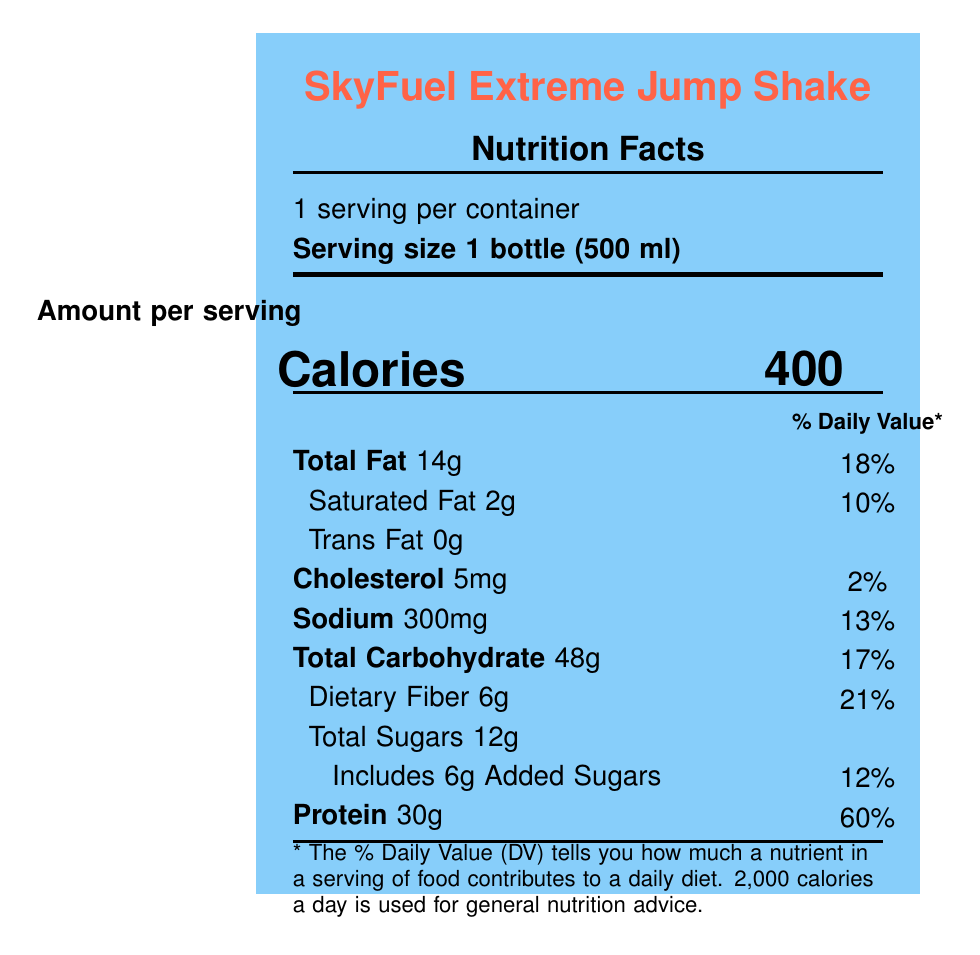what is the serving size? The serving size is shown as "1 bottle (500 ml)" under the "Serving size" section of the document.
Answer: 1 bottle (500 ml) how many servings are there per container? As indicated in the document, there is "1 serving per container."
Answer: 1 how many calories are in one serving? The document clearly states "Calories 400" under the "Amount per serving" section.
Answer: 400 what percentage of the daily value does protein account for? The document shows "Protein 30g" and "60%" next to it, indicating the percentage of the daily value.
Answer: 60% how much dietary fiber does one serving contain? Under the "Total Carbohydrate" section, the "Dietary Fiber 6g" is specified.
Answer: 6g what is the amount of saturated fat in one serving? "Saturated Fat 2g" is listed under the "Total Fat" section of the document.
Answer: 2g how much added sugars are in one serving? The document includes a line stating "Includes 6g Added Sugars."
Answer: 6g what is the percentage of the daily value for sodium? "Sodium 300mg" and "13%" are shown together indicating the daily value percentage.
Answer: 13% how much cholesterol is in one serving? A. 0mg B. 5mg C. 10mg D. 15mg The document lists "Cholesterol 5mg" under the nutrient information.
Answer: B what is the amount of Vitamin B12 in one serving? A. 0.6mcg B. 1.2mcg C. 2.4mcg D. 3.0mcg The document specifies "Vitamin B12 2.4mcg."
Answer: C is the SkyFuel Extreme Jump Shake high in protein? The document states "Protein 30g" and "60%," indicating it is high in protein.
Answer: Yes what is the total fat content per serving in grams? Listed as "Total Fat 14g" in the document's nutrient section.
Answer: 14g summarize the main features and purpose of the SkyFuel Extreme Jump Shake. The document outlines its purpose for pre-jump nutrition, the nutrient content per serving, and key features like high protein, balanced carbs, B-vitamins for focus, electrolytes for hydration, and magnesium for nerve function and muscle recovery.
Answer: The SkyFuel Extreme Jump Shake is a nutrient-dense meal replacement designed for skydivers and extreme sports enthusiasts, providing 400 calories per serving with balanced carbohydrates, high protein, essential vitamins, and minerals to support energy, mental clarity, and muscle recovery. what is the source of protein in the SkyFuel Extreme Jump Shake? The document only provides an overview of the nutrition facts and does not specify the source of the protein.
Answer: Cannot be determined 